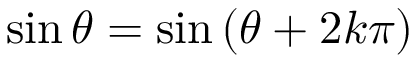<formula> <loc_0><loc_0><loc_500><loc_500>\sin \theta = \sin \left ( \theta + 2 k \pi \right )</formula> 